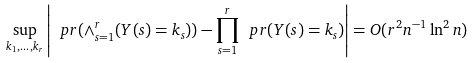Convert formula to latex. <formula><loc_0><loc_0><loc_500><loc_500>\sup _ { k _ { 1 } , \dots , k _ { r } } \left | \ p r ( \land _ { s = 1 } ^ { r } ( Y ( s ) = k _ { s } ) ) - \prod _ { s = 1 } ^ { r } \ p r ( Y ( s ) = k _ { s } ) \right | = O ( r ^ { 2 } n ^ { - 1 } \ln ^ { 2 } n )</formula> 